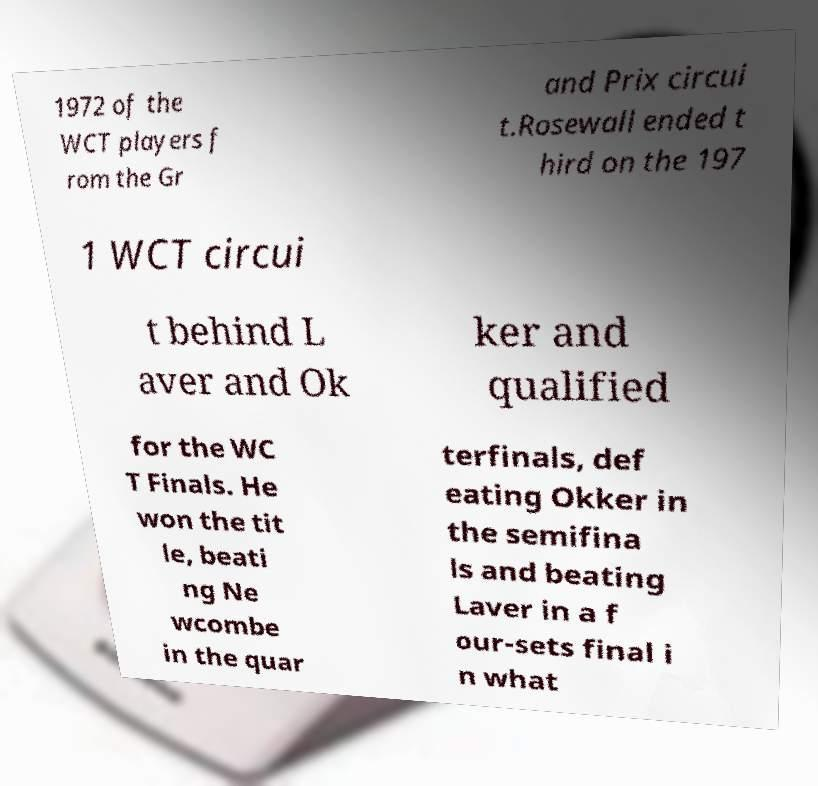There's text embedded in this image that I need extracted. Can you transcribe it verbatim? 1972 of the WCT players f rom the Gr and Prix circui t.Rosewall ended t hird on the 197 1 WCT circui t behind L aver and Ok ker and qualified for the WC T Finals. He won the tit le, beati ng Ne wcombe in the quar terfinals, def eating Okker in the semifina ls and beating Laver in a f our-sets final i n what 